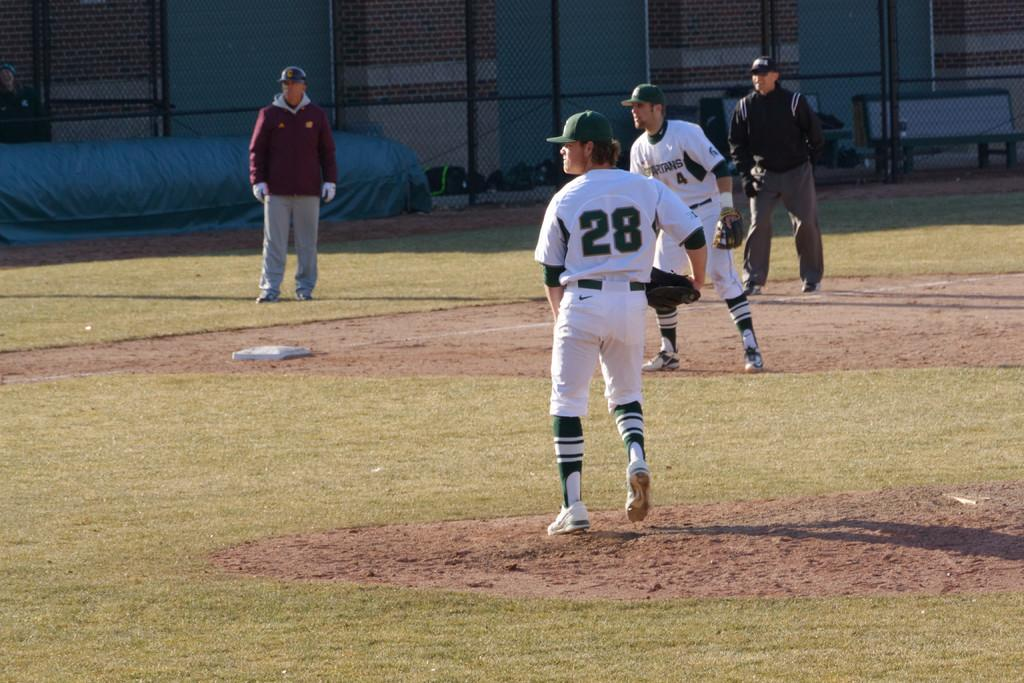<image>
Share a concise interpretation of the image provided. Two umpires and two baseball players in white and green jerseys with the numbers 28 and 4 